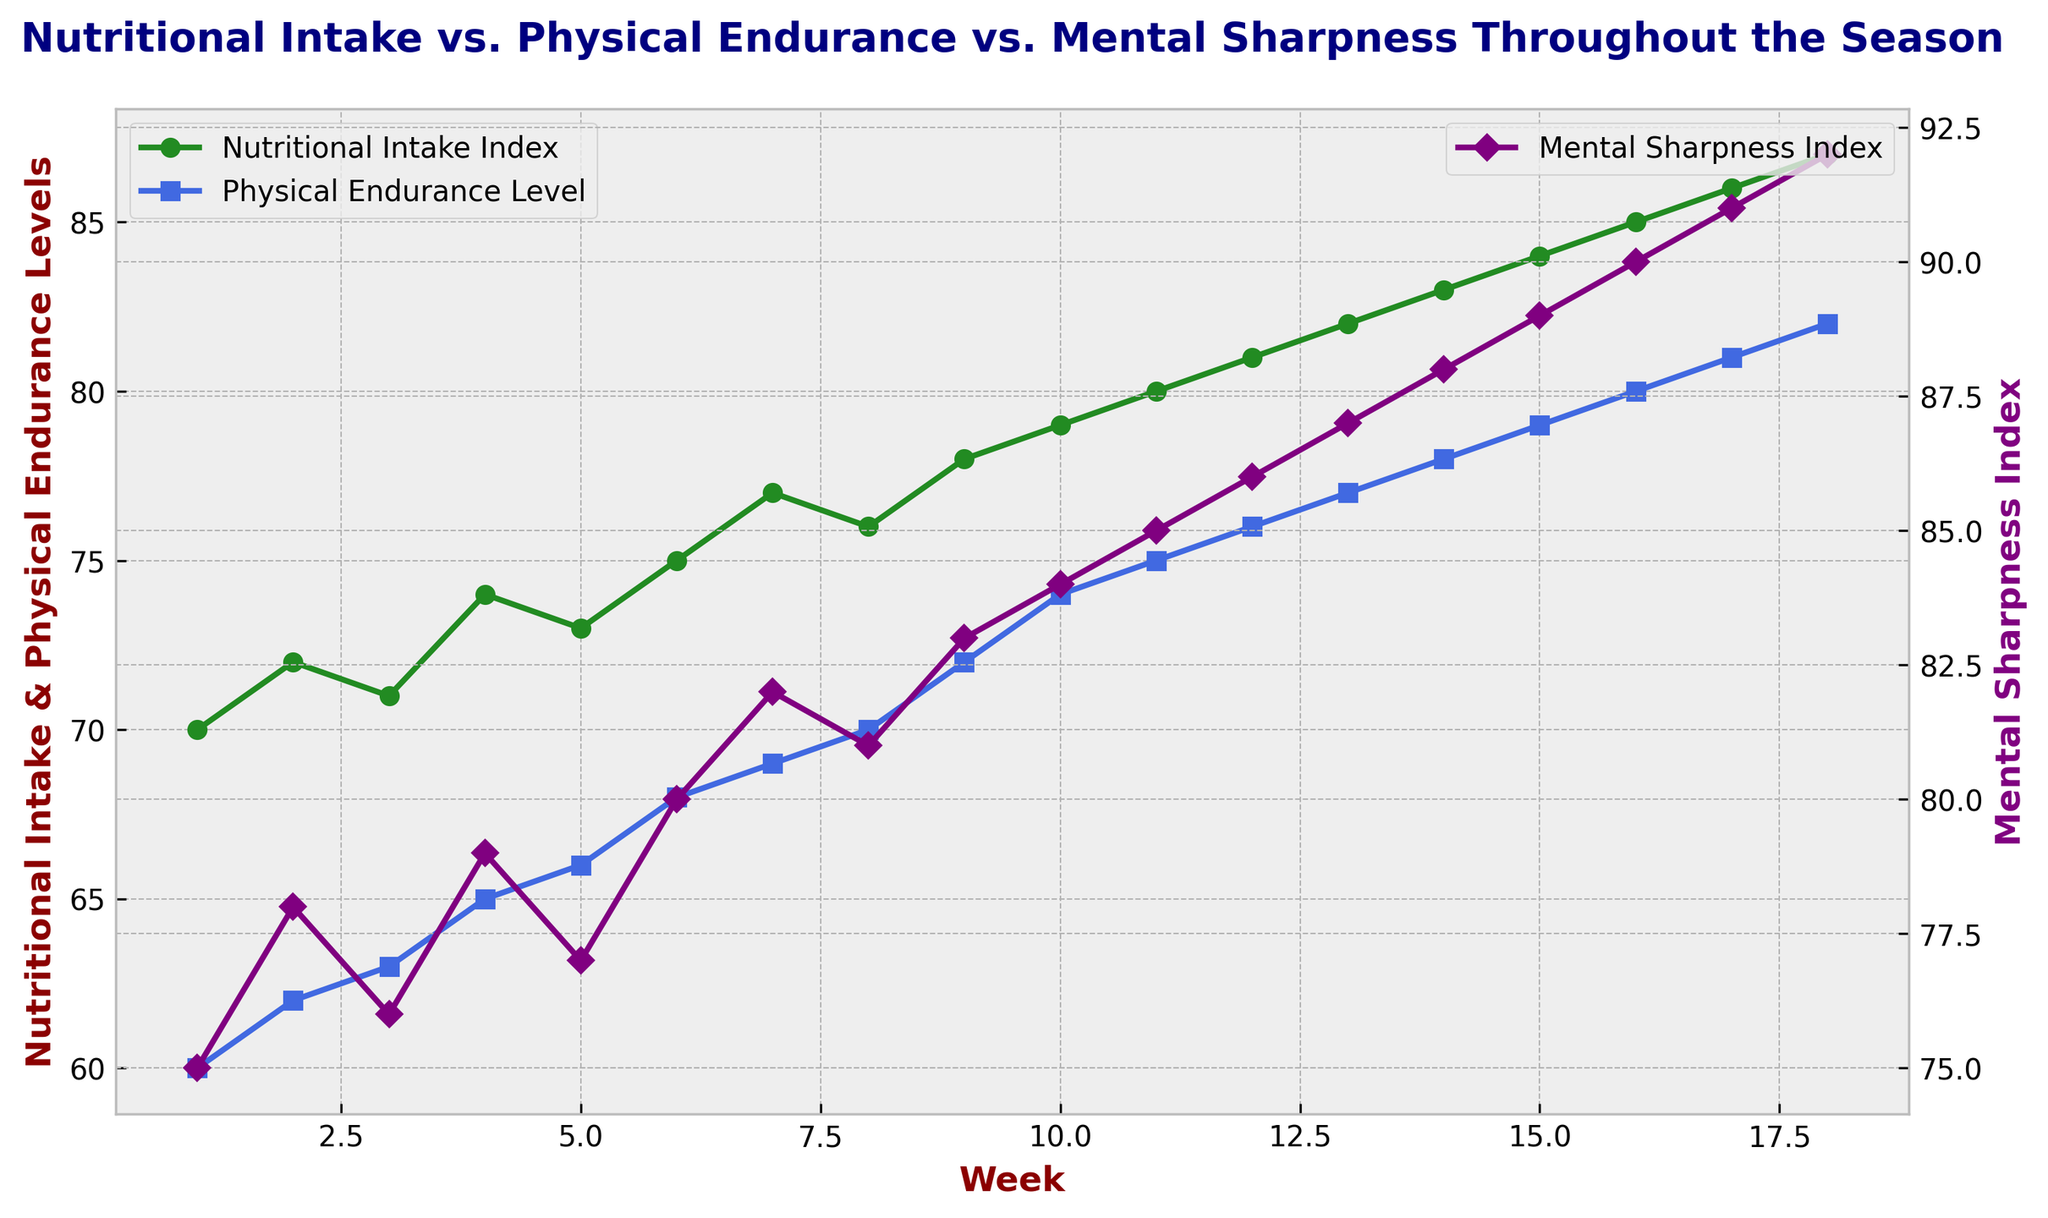What is the trend of Nutritional Intake Index from Week 1 to Week 18? By looking at the plot, we can see that the Nutritional Intake Index gradually increases from Week 1 (70) to Week 18 (87). The overall trend is upward.
Answer: Upward How does the Physical Endurance Level in Week 10 compare to the Nutritional Intake Index in the same week? In Week 10, the Physical Endurance Level is 74, while the Nutritional Intake Index is 79. By comparing these two values, we see that the Nutritional Intake Index is higher.
Answer: Nutritional Intake Index is higher During which week is the gap between Nutritional Intake Index and Mental Sharpness Index the smallest? The gap can be determined by subtracting the Nutritional Intake Index from the Mental Sharpness Index for each week. The smallest gap occurs when the difference is the least. Observing the plot, Week 18 shows both indices at 87 and 92, respectively, creating the smallest gap of 5.
Answer: Week 18 What is the mean Mental Sharpness Index in the first 5 weeks? The first 5 weeks have Mental Sharpness values of 75, 78, 76, 79, and 77. Adding these values gives 385. Dividing by 5 gives an average of 77.
Answer: 77 In which week does the Physical Endurance Level exceed 70 for the first time? The plot shows that the Physical Endurance Level first exceeds 70 in Week 9, where the value reaches 72.
Answer: Week 9 Compare the rate of increase from Week 1 to Week 10 for Nutritional Intake Index and Physical Endurance Level. Which increases more rapidly? We calculate the increase for both indices: Nutritional Intake Index increases from 70 to 79 (9 units), whereas Physical Endurance Level increases from 60 to 74 (14 units). Over 10 weeks, the Physical Endurance Level increases more rapidly (14 units vs. 9 units).
Answer: Physical Endurance Level What is the maximum Mental Sharpness Index recorded, and in which week does it occur? The highest Mental Sharpness Index seen on the plot is 92, which occurs in Week 18.
Answer: 92, Week 18 How is the trend in Physical Endurance Level from Week 1 to Week 18 visually different from the trend in Mental Sharpness Index? Visually, both trends increase, but the Mental Sharpness Index shows a steady increase with fewer fluctuations, whereas the Physical Endurance Level shows more minor fluctuations but also an overall upward trend.
Answer: Steady increase for Mental Sharpness, minor fluctuations for Physical Endurance 